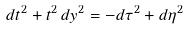<formula> <loc_0><loc_0><loc_500><loc_500>d t ^ { 2 } + t ^ { 2 } \, d y ^ { 2 } = - d \tau ^ { 2 } + d \eta ^ { 2 }</formula> 